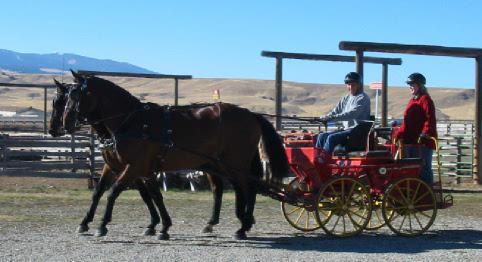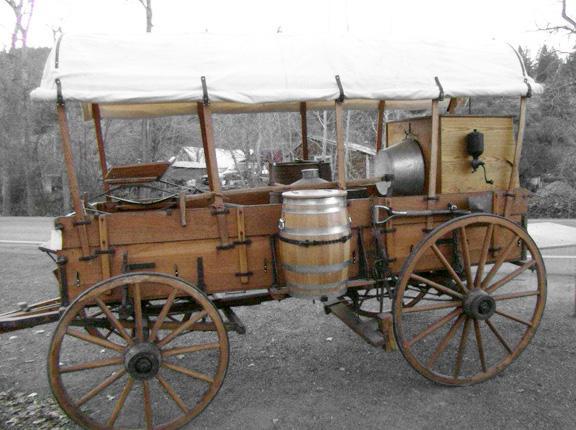The first image is the image on the left, the second image is the image on the right. Given the left and right images, does the statement "An image shows a wagon carrying at least one wooden barrel." hold true? Answer yes or no. Yes. 